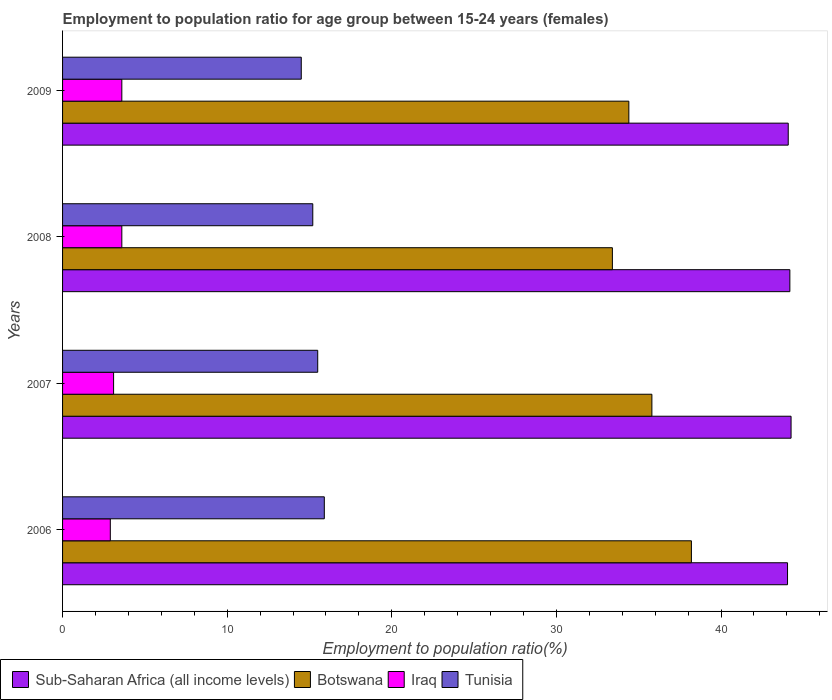How many different coloured bars are there?
Your answer should be very brief. 4. How many groups of bars are there?
Ensure brevity in your answer.  4. Are the number of bars on each tick of the Y-axis equal?
Make the answer very short. Yes. How many bars are there on the 2nd tick from the bottom?
Your response must be concise. 4. What is the employment to population ratio in Iraq in 2009?
Your response must be concise. 3.6. Across all years, what is the maximum employment to population ratio in Botswana?
Keep it short and to the point. 38.2. Across all years, what is the minimum employment to population ratio in Botswana?
Offer a terse response. 33.4. In which year was the employment to population ratio in Botswana minimum?
Your answer should be very brief. 2008. What is the total employment to population ratio in Sub-Saharan Africa (all income levels) in the graph?
Make the answer very short. 176.56. What is the difference between the employment to population ratio in Tunisia in 2006 and that in 2009?
Ensure brevity in your answer.  1.4. What is the difference between the employment to population ratio in Iraq in 2009 and the employment to population ratio in Tunisia in 2007?
Make the answer very short. -11.9. What is the average employment to population ratio in Botswana per year?
Give a very brief answer. 35.45. In the year 2006, what is the difference between the employment to population ratio in Sub-Saharan Africa (all income levels) and employment to population ratio in Botswana?
Make the answer very short. 5.84. What is the ratio of the employment to population ratio in Tunisia in 2008 to that in 2009?
Make the answer very short. 1.05. Is the employment to population ratio in Sub-Saharan Africa (all income levels) in 2006 less than that in 2007?
Keep it short and to the point. Yes. What is the difference between the highest and the second highest employment to population ratio in Botswana?
Make the answer very short. 2.4. What is the difference between the highest and the lowest employment to population ratio in Botswana?
Your answer should be compact. 4.8. In how many years, is the employment to population ratio in Botswana greater than the average employment to population ratio in Botswana taken over all years?
Offer a very short reply. 2. Is the sum of the employment to population ratio in Iraq in 2006 and 2008 greater than the maximum employment to population ratio in Botswana across all years?
Offer a terse response. No. Is it the case that in every year, the sum of the employment to population ratio in Tunisia and employment to population ratio in Iraq is greater than the sum of employment to population ratio in Botswana and employment to population ratio in Sub-Saharan Africa (all income levels)?
Give a very brief answer. No. What does the 3rd bar from the top in 2007 represents?
Provide a succinct answer. Botswana. What does the 4th bar from the bottom in 2008 represents?
Offer a very short reply. Tunisia. Are all the bars in the graph horizontal?
Make the answer very short. Yes. What is the difference between two consecutive major ticks on the X-axis?
Offer a very short reply. 10. Are the values on the major ticks of X-axis written in scientific E-notation?
Make the answer very short. No. Does the graph contain grids?
Your answer should be very brief. No. Where does the legend appear in the graph?
Make the answer very short. Bottom left. How are the legend labels stacked?
Your answer should be very brief. Horizontal. What is the title of the graph?
Your response must be concise. Employment to population ratio for age group between 15-24 years (females). What is the Employment to population ratio(%) of Sub-Saharan Africa (all income levels) in 2006?
Keep it short and to the point. 44.04. What is the Employment to population ratio(%) in Botswana in 2006?
Keep it short and to the point. 38.2. What is the Employment to population ratio(%) of Iraq in 2006?
Keep it short and to the point. 2.9. What is the Employment to population ratio(%) in Tunisia in 2006?
Offer a terse response. 15.9. What is the Employment to population ratio(%) of Sub-Saharan Africa (all income levels) in 2007?
Offer a terse response. 44.25. What is the Employment to population ratio(%) of Botswana in 2007?
Provide a succinct answer. 35.8. What is the Employment to population ratio(%) of Iraq in 2007?
Provide a short and direct response. 3.1. What is the Employment to population ratio(%) of Sub-Saharan Africa (all income levels) in 2008?
Your answer should be very brief. 44.18. What is the Employment to population ratio(%) in Botswana in 2008?
Your answer should be compact. 33.4. What is the Employment to population ratio(%) of Iraq in 2008?
Provide a succinct answer. 3.6. What is the Employment to population ratio(%) of Tunisia in 2008?
Your answer should be compact. 15.2. What is the Employment to population ratio(%) of Sub-Saharan Africa (all income levels) in 2009?
Ensure brevity in your answer.  44.08. What is the Employment to population ratio(%) in Botswana in 2009?
Keep it short and to the point. 34.4. What is the Employment to population ratio(%) in Iraq in 2009?
Offer a very short reply. 3.6. What is the Employment to population ratio(%) in Tunisia in 2009?
Provide a short and direct response. 14.5. Across all years, what is the maximum Employment to population ratio(%) of Sub-Saharan Africa (all income levels)?
Your response must be concise. 44.25. Across all years, what is the maximum Employment to population ratio(%) of Botswana?
Ensure brevity in your answer.  38.2. Across all years, what is the maximum Employment to population ratio(%) of Iraq?
Your response must be concise. 3.6. Across all years, what is the maximum Employment to population ratio(%) in Tunisia?
Keep it short and to the point. 15.9. Across all years, what is the minimum Employment to population ratio(%) of Sub-Saharan Africa (all income levels)?
Ensure brevity in your answer.  44.04. Across all years, what is the minimum Employment to population ratio(%) in Botswana?
Make the answer very short. 33.4. Across all years, what is the minimum Employment to population ratio(%) in Iraq?
Your answer should be very brief. 2.9. What is the total Employment to population ratio(%) in Sub-Saharan Africa (all income levels) in the graph?
Keep it short and to the point. 176.56. What is the total Employment to population ratio(%) of Botswana in the graph?
Your answer should be compact. 141.8. What is the total Employment to population ratio(%) in Iraq in the graph?
Your answer should be compact. 13.2. What is the total Employment to population ratio(%) of Tunisia in the graph?
Your answer should be very brief. 61.1. What is the difference between the Employment to population ratio(%) in Sub-Saharan Africa (all income levels) in 2006 and that in 2007?
Offer a terse response. -0.21. What is the difference between the Employment to population ratio(%) of Iraq in 2006 and that in 2007?
Your answer should be compact. -0.2. What is the difference between the Employment to population ratio(%) in Tunisia in 2006 and that in 2007?
Ensure brevity in your answer.  0.4. What is the difference between the Employment to population ratio(%) in Sub-Saharan Africa (all income levels) in 2006 and that in 2008?
Give a very brief answer. -0.14. What is the difference between the Employment to population ratio(%) in Tunisia in 2006 and that in 2008?
Offer a terse response. 0.7. What is the difference between the Employment to population ratio(%) in Sub-Saharan Africa (all income levels) in 2006 and that in 2009?
Your answer should be compact. -0.04. What is the difference between the Employment to population ratio(%) of Iraq in 2006 and that in 2009?
Provide a short and direct response. -0.7. What is the difference between the Employment to population ratio(%) of Sub-Saharan Africa (all income levels) in 2007 and that in 2008?
Make the answer very short. 0.07. What is the difference between the Employment to population ratio(%) of Sub-Saharan Africa (all income levels) in 2007 and that in 2009?
Your response must be concise. 0.17. What is the difference between the Employment to population ratio(%) of Botswana in 2007 and that in 2009?
Provide a succinct answer. 1.4. What is the difference between the Employment to population ratio(%) of Iraq in 2007 and that in 2009?
Offer a terse response. -0.5. What is the difference between the Employment to population ratio(%) of Sub-Saharan Africa (all income levels) in 2008 and that in 2009?
Offer a terse response. 0.1. What is the difference between the Employment to population ratio(%) of Iraq in 2008 and that in 2009?
Provide a short and direct response. 0. What is the difference between the Employment to population ratio(%) in Sub-Saharan Africa (all income levels) in 2006 and the Employment to population ratio(%) in Botswana in 2007?
Your answer should be compact. 8.24. What is the difference between the Employment to population ratio(%) in Sub-Saharan Africa (all income levels) in 2006 and the Employment to population ratio(%) in Iraq in 2007?
Provide a short and direct response. 40.94. What is the difference between the Employment to population ratio(%) in Sub-Saharan Africa (all income levels) in 2006 and the Employment to population ratio(%) in Tunisia in 2007?
Provide a succinct answer. 28.54. What is the difference between the Employment to population ratio(%) of Botswana in 2006 and the Employment to population ratio(%) of Iraq in 2007?
Ensure brevity in your answer.  35.1. What is the difference between the Employment to population ratio(%) in Botswana in 2006 and the Employment to population ratio(%) in Tunisia in 2007?
Ensure brevity in your answer.  22.7. What is the difference between the Employment to population ratio(%) in Iraq in 2006 and the Employment to population ratio(%) in Tunisia in 2007?
Offer a terse response. -12.6. What is the difference between the Employment to population ratio(%) of Sub-Saharan Africa (all income levels) in 2006 and the Employment to population ratio(%) of Botswana in 2008?
Ensure brevity in your answer.  10.64. What is the difference between the Employment to population ratio(%) of Sub-Saharan Africa (all income levels) in 2006 and the Employment to population ratio(%) of Iraq in 2008?
Offer a terse response. 40.44. What is the difference between the Employment to population ratio(%) in Sub-Saharan Africa (all income levels) in 2006 and the Employment to population ratio(%) in Tunisia in 2008?
Provide a succinct answer. 28.84. What is the difference between the Employment to population ratio(%) in Botswana in 2006 and the Employment to population ratio(%) in Iraq in 2008?
Your answer should be very brief. 34.6. What is the difference between the Employment to population ratio(%) in Botswana in 2006 and the Employment to population ratio(%) in Tunisia in 2008?
Your response must be concise. 23. What is the difference between the Employment to population ratio(%) in Sub-Saharan Africa (all income levels) in 2006 and the Employment to population ratio(%) in Botswana in 2009?
Ensure brevity in your answer.  9.64. What is the difference between the Employment to population ratio(%) in Sub-Saharan Africa (all income levels) in 2006 and the Employment to population ratio(%) in Iraq in 2009?
Offer a very short reply. 40.44. What is the difference between the Employment to population ratio(%) of Sub-Saharan Africa (all income levels) in 2006 and the Employment to population ratio(%) of Tunisia in 2009?
Provide a succinct answer. 29.54. What is the difference between the Employment to population ratio(%) in Botswana in 2006 and the Employment to population ratio(%) in Iraq in 2009?
Offer a terse response. 34.6. What is the difference between the Employment to population ratio(%) in Botswana in 2006 and the Employment to population ratio(%) in Tunisia in 2009?
Offer a terse response. 23.7. What is the difference between the Employment to population ratio(%) of Sub-Saharan Africa (all income levels) in 2007 and the Employment to population ratio(%) of Botswana in 2008?
Provide a succinct answer. 10.85. What is the difference between the Employment to population ratio(%) in Sub-Saharan Africa (all income levels) in 2007 and the Employment to population ratio(%) in Iraq in 2008?
Provide a succinct answer. 40.65. What is the difference between the Employment to population ratio(%) in Sub-Saharan Africa (all income levels) in 2007 and the Employment to population ratio(%) in Tunisia in 2008?
Provide a short and direct response. 29.05. What is the difference between the Employment to population ratio(%) of Botswana in 2007 and the Employment to population ratio(%) of Iraq in 2008?
Your answer should be very brief. 32.2. What is the difference between the Employment to population ratio(%) of Botswana in 2007 and the Employment to population ratio(%) of Tunisia in 2008?
Provide a short and direct response. 20.6. What is the difference between the Employment to population ratio(%) in Sub-Saharan Africa (all income levels) in 2007 and the Employment to population ratio(%) in Botswana in 2009?
Keep it short and to the point. 9.85. What is the difference between the Employment to population ratio(%) in Sub-Saharan Africa (all income levels) in 2007 and the Employment to population ratio(%) in Iraq in 2009?
Ensure brevity in your answer.  40.65. What is the difference between the Employment to population ratio(%) of Sub-Saharan Africa (all income levels) in 2007 and the Employment to population ratio(%) of Tunisia in 2009?
Give a very brief answer. 29.75. What is the difference between the Employment to population ratio(%) in Botswana in 2007 and the Employment to population ratio(%) in Iraq in 2009?
Your answer should be very brief. 32.2. What is the difference between the Employment to population ratio(%) in Botswana in 2007 and the Employment to population ratio(%) in Tunisia in 2009?
Ensure brevity in your answer.  21.3. What is the difference between the Employment to population ratio(%) in Iraq in 2007 and the Employment to population ratio(%) in Tunisia in 2009?
Offer a very short reply. -11.4. What is the difference between the Employment to population ratio(%) of Sub-Saharan Africa (all income levels) in 2008 and the Employment to population ratio(%) of Botswana in 2009?
Ensure brevity in your answer.  9.78. What is the difference between the Employment to population ratio(%) in Sub-Saharan Africa (all income levels) in 2008 and the Employment to population ratio(%) in Iraq in 2009?
Your answer should be compact. 40.58. What is the difference between the Employment to population ratio(%) in Sub-Saharan Africa (all income levels) in 2008 and the Employment to population ratio(%) in Tunisia in 2009?
Give a very brief answer. 29.68. What is the difference between the Employment to population ratio(%) of Botswana in 2008 and the Employment to population ratio(%) of Iraq in 2009?
Ensure brevity in your answer.  29.8. What is the difference between the Employment to population ratio(%) of Botswana in 2008 and the Employment to population ratio(%) of Tunisia in 2009?
Make the answer very short. 18.9. What is the difference between the Employment to population ratio(%) in Iraq in 2008 and the Employment to population ratio(%) in Tunisia in 2009?
Your answer should be very brief. -10.9. What is the average Employment to population ratio(%) of Sub-Saharan Africa (all income levels) per year?
Provide a short and direct response. 44.14. What is the average Employment to population ratio(%) in Botswana per year?
Your answer should be very brief. 35.45. What is the average Employment to population ratio(%) in Tunisia per year?
Provide a short and direct response. 15.28. In the year 2006, what is the difference between the Employment to population ratio(%) in Sub-Saharan Africa (all income levels) and Employment to population ratio(%) in Botswana?
Provide a succinct answer. 5.84. In the year 2006, what is the difference between the Employment to population ratio(%) in Sub-Saharan Africa (all income levels) and Employment to population ratio(%) in Iraq?
Give a very brief answer. 41.14. In the year 2006, what is the difference between the Employment to population ratio(%) in Sub-Saharan Africa (all income levels) and Employment to population ratio(%) in Tunisia?
Offer a terse response. 28.14. In the year 2006, what is the difference between the Employment to population ratio(%) in Botswana and Employment to population ratio(%) in Iraq?
Offer a very short reply. 35.3. In the year 2006, what is the difference between the Employment to population ratio(%) in Botswana and Employment to population ratio(%) in Tunisia?
Offer a terse response. 22.3. In the year 2006, what is the difference between the Employment to population ratio(%) in Iraq and Employment to population ratio(%) in Tunisia?
Give a very brief answer. -13. In the year 2007, what is the difference between the Employment to population ratio(%) in Sub-Saharan Africa (all income levels) and Employment to population ratio(%) in Botswana?
Provide a short and direct response. 8.45. In the year 2007, what is the difference between the Employment to population ratio(%) in Sub-Saharan Africa (all income levels) and Employment to population ratio(%) in Iraq?
Offer a terse response. 41.15. In the year 2007, what is the difference between the Employment to population ratio(%) in Sub-Saharan Africa (all income levels) and Employment to population ratio(%) in Tunisia?
Your answer should be compact. 28.75. In the year 2007, what is the difference between the Employment to population ratio(%) of Botswana and Employment to population ratio(%) of Iraq?
Your answer should be compact. 32.7. In the year 2007, what is the difference between the Employment to population ratio(%) of Botswana and Employment to population ratio(%) of Tunisia?
Offer a terse response. 20.3. In the year 2008, what is the difference between the Employment to population ratio(%) in Sub-Saharan Africa (all income levels) and Employment to population ratio(%) in Botswana?
Ensure brevity in your answer.  10.78. In the year 2008, what is the difference between the Employment to population ratio(%) in Sub-Saharan Africa (all income levels) and Employment to population ratio(%) in Iraq?
Provide a short and direct response. 40.58. In the year 2008, what is the difference between the Employment to population ratio(%) in Sub-Saharan Africa (all income levels) and Employment to population ratio(%) in Tunisia?
Give a very brief answer. 28.98. In the year 2008, what is the difference between the Employment to population ratio(%) in Botswana and Employment to population ratio(%) in Iraq?
Provide a succinct answer. 29.8. In the year 2008, what is the difference between the Employment to population ratio(%) of Botswana and Employment to population ratio(%) of Tunisia?
Make the answer very short. 18.2. In the year 2008, what is the difference between the Employment to population ratio(%) of Iraq and Employment to population ratio(%) of Tunisia?
Provide a succinct answer. -11.6. In the year 2009, what is the difference between the Employment to population ratio(%) of Sub-Saharan Africa (all income levels) and Employment to population ratio(%) of Botswana?
Offer a very short reply. 9.68. In the year 2009, what is the difference between the Employment to population ratio(%) in Sub-Saharan Africa (all income levels) and Employment to population ratio(%) in Iraq?
Ensure brevity in your answer.  40.48. In the year 2009, what is the difference between the Employment to population ratio(%) in Sub-Saharan Africa (all income levels) and Employment to population ratio(%) in Tunisia?
Keep it short and to the point. 29.58. In the year 2009, what is the difference between the Employment to population ratio(%) in Botswana and Employment to population ratio(%) in Iraq?
Your response must be concise. 30.8. In the year 2009, what is the difference between the Employment to population ratio(%) in Botswana and Employment to population ratio(%) in Tunisia?
Make the answer very short. 19.9. What is the ratio of the Employment to population ratio(%) in Sub-Saharan Africa (all income levels) in 2006 to that in 2007?
Provide a short and direct response. 1. What is the ratio of the Employment to population ratio(%) of Botswana in 2006 to that in 2007?
Offer a terse response. 1.07. What is the ratio of the Employment to population ratio(%) in Iraq in 2006 to that in 2007?
Offer a terse response. 0.94. What is the ratio of the Employment to population ratio(%) in Tunisia in 2006 to that in 2007?
Ensure brevity in your answer.  1.03. What is the ratio of the Employment to population ratio(%) of Sub-Saharan Africa (all income levels) in 2006 to that in 2008?
Provide a succinct answer. 1. What is the ratio of the Employment to population ratio(%) in Botswana in 2006 to that in 2008?
Offer a terse response. 1.14. What is the ratio of the Employment to population ratio(%) of Iraq in 2006 to that in 2008?
Make the answer very short. 0.81. What is the ratio of the Employment to population ratio(%) in Tunisia in 2006 to that in 2008?
Keep it short and to the point. 1.05. What is the ratio of the Employment to population ratio(%) in Botswana in 2006 to that in 2009?
Make the answer very short. 1.11. What is the ratio of the Employment to population ratio(%) in Iraq in 2006 to that in 2009?
Give a very brief answer. 0.81. What is the ratio of the Employment to population ratio(%) of Tunisia in 2006 to that in 2009?
Provide a short and direct response. 1.1. What is the ratio of the Employment to population ratio(%) in Botswana in 2007 to that in 2008?
Give a very brief answer. 1.07. What is the ratio of the Employment to population ratio(%) in Iraq in 2007 to that in 2008?
Your answer should be compact. 0.86. What is the ratio of the Employment to population ratio(%) of Tunisia in 2007 to that in 2008?
Ensure brevity in your answer.  1.02. What is the ratio of the Employment to population ratio(%) in Sub-Saharan Africa (all income levels) in 2007 to that in 2009?
Your answer should be compact. 1. What is the ratio of the Employment to population ratio(%) in Botswana in 2007 to that in 2009?
Make the answer very short. 1.04. What is the ratio of the Employment to population ratio(%) in Iraq in 2007 to that in 2009?
Your response must be concise. 0.86. What is the ratio of the Employment to population ratio(%) of Tunisia in 2007 to that in 2009?
Provide a short and direct response. 1.07. What is the ratio of the Employment to population ratio(%) in Sub-Saharan Africa (all income levels) in 2008 to that in 2009?
Keep it short and to the point. 1. What is the ratio of the Employment to population ratio(%) of Botswana in 2008 to that in 2009?
Offer a terse response. 0.97. What is the ratio of the Employment to population ratio(%) of Iraq in 2008 to that in 2009?
Ensure brevity in your answer.  1. What is the ratio of the Employment to population ratio(%) of Tunisia in 2008 to that in 2009?
Your response must be concise. 1.05. What is the difference between the highest and the second highest Employment to population ratio(%) in Sub-Saharan Africa (all income levels)?
Make the answer very short. 0.07. What is the difference between the highest and the second highest Employment to population ratio(%) in Botswana?
Keep it short and to the point. 2.4. What is the difference between the highest and the lowest Employment to population ratio(%) in Sub-Saharan Africa (all income levels)?
Provide a short and direct response. 0.21. What is the difference between the highest and the lowest Employment to population ratio(%) of Iraq?
Give a very brief answer. 0.7. What is the difference between the highest and the lowest Employment to population ratio(%) of Tunisia?
Your answer should be compact. 1.4. 